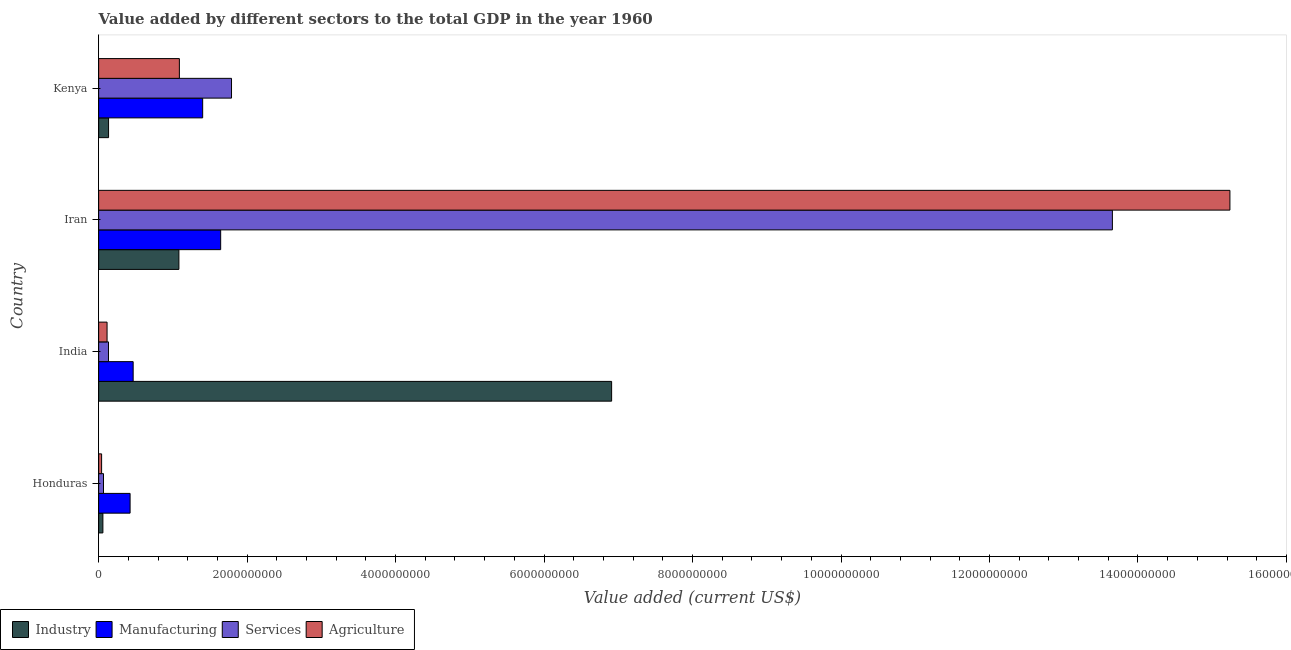How many groups of bars are there?
Make the answer very short. 4. Are the number of bars per tick equal to the number of legend labels?
Offer a very short reply. Yes. Are the number of bars on each tick of the Y-axis equal?
Make the answer very short. Yes. How many bars are there on the 3rd tick from the bottom?
Give a very brief answer. 4. What is the label of the 4th group of bars from the top?
Your response must be concise. Honduras. What is the value added by manufacturing sector in India?
Your answer should be compact. 4.65e+08. Across all countries, what is the maximum value added by industrial sector?
Your answer should be compact. 6.91e+09. Across all countries, what is the minimum value added by manufacturing sector?
Provide a succinct answer. 4.24e+08. In which country was the value added by services sector maximum?
Provide a short and direct response. Iran. In which country was the value added by services sector minimum?
Provide a short and direct response. Honduras. What is the total value added by agricultural sector in the graph?
Give a very brief answer. 1.65e+1. What is the difference between the value added by industrial sector in Honduras and that in Kenya?
Provide a short and direct response. -7.63e+07. What is the difference between the value added by services sector in Iran and the value added by manufacturing sector in India?
Provide a succinct answer. 1.32e+1. What is the average value added by agricultural sector per country?
Offer a terse response. 4.12e+09. What is the difference between the value added by industrial sector and value added by agricultural sector in India?
Your answer should be very brief. 6.80e+09. In how many countries, is the value added by services sector greater than 12000000000 US$?
Provide a short and direct response. 1. What is the ratio of the value added by manufacturing sector in Honduras to that in Kenya?
Offer a terse response. 0.3. Is the value added by agricultural sector in India less than that in Kenya?
Provide a succinct answer. Yes. Is the difference between the value added by industrial sector in Honduras and Kenya greater than the difference between the value added by services sector in Honduras and Kenya?
Provide a succinct answer. Yes. What is the difference between the highest and the second highest value added by agricultural sector?
Give a very brief answer. 1.42e+1. What is the difference between the highest and the lowest value added by manufacturing sector?
Provide a succinct answer. 1.22e+09. Is the sum of the value added by manufacturing sector in Honduras and Iran greater than the maximum value added by services sector across all countries?
Your response must be concise. No. What does the 1st bar from the top in Kenya represents?
Your answer should be compact. Agriculture. What does the 1st bar from the bottom in Kenya represents?
Give a very brief answer. Industry. How many bars are there?
Provide a short and direct response. 16. Are all the bars in the graph horizontal?
Your response must be concise. Yes. How many countries are there in the graph?
Offer a very short reply. 4. What is the difference between two consecutive major ticks on the X-axis?
Your answer should be very brief. 2.00e+09. Are the values on the major ticks of X-axis written in scientific E-notation?
Give a very brief answer. No. Does the graph contain any zero values?
Your answer should be compact. No. Where does the legend appear in the graph?
Your answer should be compact. Bottom left. How many legend labels are there?
Give a very brief answer. 4. How are the legend labels stacked?
Give a very brief answer. Horizontal. What is the title of the graph?
Offer a terse response. Value added by different sectors to the total GDP in the year 1960. Does "Public sector management" appear as one of the legend labels in the graph?
Provide a short and direct response. No. What is the label or title of the X-axis?
Offer a very short reply. Value added (current US$). What is the Value added (current US$) of Industry in Honduras?
Offer a very short reply. 5.73e+07. What is the Value added (current US$) in Manufacturing in Honduras?
Provide a short and direct response. 4.24e+08. What is the Value added (current US$) in Services in Honduras?
Keep it short and to the point. 6.55e+07. What is the Value added (current US$) in Agriculture in Honduras?
Offer a terse response. 4.01e+07. What is the Value added (current US$) of Industry in India?
Your answer should be very brief. 6.91e+09. What is the Value added (current US$) of Manufacturing in India?
Provide a short and direct response. 4.65e+08. What is the Value added (current US$) of Services in India?
Make the answer very short. 1.33e+08. What is the Value added (current US$) in Agriculture in India?
Offer a very short reply. 1.14e+08. What is the Value added (current US$) in Industry in Iran?
Your answer should be very brief. 1.08e+09. What is the Value added (current US$) in Manufacturing in Iran?
Keep it short and to the point. 1.64e+09. What is the Value added (current US$) in Services in Iran?
Provide a succinct answer. 1.37e+1. What is the Value added (current US$) of Agriculture in Iran?
Make the answer very short. 1.52e+1. What is the Value added (current US$) in Industry in Kenya?
Make the answer very short. 1.34e+08. What is the Value added (current US$) of Manufacturing in Kenya?
Keep it short and to the point. 1.40e+09. What is the Value added (current US$) of Services in Kenya?
Ensure brevity in your answer.  1.79e+09. What is the Value added (current US$) of Agriculture in Kenya?
Your answer should be compact. 1.09e+09. Across all countries, what is the maximum Value added (current US$) in Industry?
Your response must be concise. 6.91e+09. Across all countries, what is the maximum Value added (current US$) in Manufacturing?
Keep it short and to the point. 1.64e+09. Across all countries, what is the maximum Value added (current US$) in Services?
Offer a terse response. 1.37e+1. Across all countries, what is the maximum Value added (current US$) in Agriculture?
Your response must be concise. 1.52e+1. Across all countries, what is the minimum Value added (current US$) in Industry?
Provide a short and direct response. 5.73e+07. Across all countries, what is the minimum Value added (current US$) of Manufacturing?
Your answer should be very brief. 4.24e+08. Across all countries, what is the minimum Value added (current US$) of Services?
Offer a very short reply. 6.55e+07. Across all countries, what is the minimum Value added (current US$) in Agriculture?
Keep it short and to the point. 4.01e+07. What is the total Value added (current US$) of Industry in the graph?
Keep it short and to the point. 8.18e+09. What is the total Value added (current US$) of Manufacturing in the graph?
Provide a short and direct response. 3.93e+09. What is the total Value added (current US$) of Services in the graph?
Offer a terse response. 1.56e+1. What is the total Value added (current US$) in Agriculture in the graph?
Provide a short and direct response. 1.65e+1. What is the difference between the Value added (current US$) in Industry in Honduras and that in India?
Keep it short and to the point. -6.85e+09. What is the difference between the Value added (current US$) of Manufacturing in Honduras and that in India?
Make the answer very short. -4.13e+07. What is the difference between the Value added (current US$) in Services in Honduras and that in India?
Provide a short and direct response. -6.71e+07. What is the difference between the Value added (current US$) of Agriculture in Honduras and that in India?
Provide a short and direct response. -7.34e+07. What is the difference between the Value added (current US$) of Industry in Honduras and that in Iran?
Offer a terse response. -1.02e+09. What is the difference between the Value added (current US$) of Manufacturing in Honduras and that in Iran?
Your response must be concise. -1.22e+09. What is the difference between the Value added (current US$) in Services in Honduras and that in Iran?
Your answer should be very brief. -1.36e+1. What is the difference between the Value added (current US$) in Agriculture in Honduras and that in Iran?
Offer a terse response. -1.52e+1. What is the difference between the Value added (current US$) of Industry in Honduras and that in Kenya?
Offer a very short reply. -7.63e+07. What is the difference between the Value added (current US$) in Manufacturing in Honduras and that in Kenya?
Offer a very short reply. -9.78e+08. What is the difference between the Value added (current US$) in Services in Honduras and that in Kenya?
Make the answer very short. -1.72e+09. What is the difference between the Value added (current US$) of Agriculture in Honduras and that in Kenya?
Ensure brevity in your answer.  -1.05e+09. What is the difference between the Value added (current US$) in Industry in India and that in Iran?
Ensure brevity in your answer.  5.83e+09. What is the difference between the Value added (current US$) in Manufacturing in India and that in Iran?
Provide a succinct answer. -1.18e+09. What is the difference between the Value added (current US$) in Services in India and that in Iran?
Offer a very short reply. -1.35e+1. What is the difference between the Value added (current US$) in Agriculture in India and that in Iran?
Offer a very short reply. -1.51e+1. What is the difference between the Value added (current US$) in Industry in India and that in Kenya?
Provide a short and direct response. 6.78e+09. What is the difference between the Value added (current US$) in Manufacturing in India and that in Kenya?
Provide a succinct answer. -9.36e+08. What is the difference between the Value added (current US$) in Services in India and that in Kenya?
Give a very brief answer. -1.66e+09. What is the difference between the Value added (current US$) in Agriculture in India and that in Kenya?
Ensure brevity in your answer.  -9.74e+08. What is the difference between the Value added (current US$) of Industry in Iran and that in Kenya?
Keep it short and to the point. 9.48e+08. What is the difference between the Value added (current US$) in Manufacturing in Iran and that in Kenya?
Offer a very short reply. 2.43e+08. What is the difference between the Value added (current US$) of Services in Iran and that in Kenya?
Offer a very short reply. 1.19e+1. What is the difference between the Value added (current US$) of Agriculture in Iran and that in Kenya?
Make the answer very short. 1.42e+1. What is the difference between the Value added (current US$) in Industry in Honduras and the Value added (current US$) in Manufacturing in India?
Your answer should be very brief. -4.08e+08. What is the difference between the Value added (current US$) in Industry in Honduras and the Value added (current US$) in Services in India?
Offer a very short reply. -7.53e+07. What is the difference between the Value added (current US$) in Industry in Honduras and the Value added (current US$) in Agriculture in India?
Make the answer very short. -5.62e+07. What is the difference between the Value added (current US$) of Manufacturing in Honduras and the Value added (current US$) of Services in India?
Your answer should be compact. 2.91e+08. What is the difference between the Value added (current US$) of Manufacturing in Honduras and the Value added (current US$) of Agriculture in India?
Offer a very short reply. 3.10e+08. What is the difference between the Value added (current US$) in Services in Honduras and the Value added (current US$) in Agriculture in India?
Provide a short and direct response. -4.80e+07. What is the difference between the Value added (current US$) in Industry in Honduras and the Value added (current US$) in Manufacturing in Iran?
Keep it short and to the point. -1.59e+09. What is the difference between the Value added (current US$) of Industry in Honduras and the Value added (current US$) of Services in Iran?
Ensure brevity in your answer.  -1.36e+1. What is the difference between the Value added (current US$) of Industry in Honduras and the Value added (current US$) of Agriculture in Iran?
Give a very brief answer. -1.52e+1. What is the difference between the Value added (current US$) in Manufacturing in Honduras and the Value added (current US$) in Services in Iran?
Offer a very short reply. -1.32e+1. What is the difference between the Value added (current US$) of Manufacturing in Honduras and the Value added (current US$) of Agriculture in Iran?
Your response must be concise. -1.48e+1. What is the difference between the Value added (current US$) of Services in Honduras and the Value added (current US$) of Agriculture in Iran?
Provide a short and direct response. -1.52e+1. What is the difference between the Value added (current US$) of Industry in Honduras and the Value added (current US$) of Manufacturing in Kenya?
Your answer should be very brief. -1.34e+09. What is the difference between the Value added (current US$) in Industry in Honduras and the Value added (current US$) in Services in Kenya?
Provide a succinct answer. -1.73e+09. What is the difference between the Value added (current US$) of Industry in Honduras and the Value added (current US$) of Agriculture in Kenya?
Your response must be concise. -1.03e+09. What is the difference between the Value added (current US$) of Manufacturing in Honduras and the Value added (current US$) of Services in Kenya?
Your answer should be very brief. -1.37e+09. What is the difference between the Value added (current US$) in Manufacturing in Honduras and the Value added (current US$) in Agriculture in Kenya?
Provide a short and direct response. -6.64e+08. What is the difference between the Value added (current US$) of Services in Honduras and the Value added (current US$) of Agriculture in Kenya?
Provide a succinct answer. -1.02e+09. What is the difference between the Value added (current US$) in Industry in India and the Value added (current US$) in Manufacturing in Iran?
Keep it short and to the point. 5.27e+09. What is the difference between the Value added (current US$) in Industry in India and the Value added (current US$) in Services in Iran?
Your response must be concise. -6.75e+09. What is the difference between the Value added (current US$) of Industry in India and the Value added (current US$) of Agriculture in Iran?
Make the answer very short. -8.33e+09. What is the difference between the Value added (current US$) in Manufacturing in India and the Value added (current US$) in Services in Iran?
Offer a terse response. -1.32e+1. What is the difference between the Value added (current US$) in Manufacturing in India and the Value added (current US$) in Agriculture in Iran?
Your response must be concise. -1.48e+1. What is the difference between the Value added (current US$) of Services in India and the Value added (current US$) of Agriculture in Iran?
Your response must be concise. -1.51e+1. What is the difference between the Value added (current US$) in Industry in India and the Value added (current US$) in Manufacturing in Kenya?
Your answer should be compact. 5.51e+09. What is the difference between the Value added (current US$) of Industry in India and the Value added (current US$) of Services in Kenya?
Ensure brevity in your answer.  5.12e+09. What is the difference between the Value added (current US$) in Industry in India and the Value added (current US$) in Agriculture in Kenya?
Your response must be concise. 5.82e+09. What is the difference between the Value added (current US$) of Manufacturing in India and the Value added (current US$) of Services in Kenya?
Provide a succinct answer. -1.32e+09. What is the difference between the Value added (current US$) of Manufacturing in India and the Value added (current US$) of Agriculture in Kenya?
Make the answer very short. -6.22e+08. What is the difference between the Value added (current US$) of Services in India and the Value added (current US$) of Agriculture in Kenya?
Ensure brevity in your answer.  -9.55e+08. What is the difference between the Value added (current US$) in Industry in Iran and the Value added (current US$) in Manufacturing in Kenya?
Your response must be concise. -3.20e+08. What is the difference between the Value added (current US$) in Industry in Iran and the Value added (current US$) in Services in Kenya?
Offer a terse response. -7.09e+08. What is the difference between the Value added (current US$) in Industry in Iran and the Value added (current US$) in Agriculture in Kenya?
Provide a succinct answer. -6.43e+06. What is the difference between the Value added (current US$) of Manufacturing in Iran and the Value added (current US$) of Services in Kenya?
Keep it short and to the point. -1.46e+08. What is the difference between the Value added (current US$) of Manufacturing in Iran and the Value added (current US$) of Agriculture in Kenya?
Give a very brief answer. 5.56e+08. What is the difference between the Value added (current US$) in Services in Iran and the Value added (current US$) in Agriculture in Kenya?
Ensure brevity in your answer.  1.26e+1. What is the average Value added (current US$) in Industry per country?
Your answer should be very brief. 2.05e+09. What is the average Value added (current US$) of Manufacturing per country?
Ensure brevity in your answer.  9.84e+08. What is the average Value added (current US$) of Services per country?
Provide a succinct answer. 3.91e+09. What is the average Value added (current US$) of Agriculture per country?
Offer a terse response. 4.12e+09. What is the difference between the Value added (current US$) of Industry and Value added (current US$) of Manufacturing in Honduras?
Provide a succinct answer. -3.66e+08. What is the difference between the Value added (current US$) of Industry and Value added (current US$) of Services in Honduras?
Offer a terse response. -8.21e+06. What is the difference between the Value added (current US$) in Industry and Value added (current US$) in Agriculture in Honduras?
Give a very brief answer. 1.72e+07. What is the difference between the Value added (current US$) in Manufacturing and Value added (current US$) in Services in Honduras?
Give a very brief answer. 3.58e+08. What is the difference between the Value added (current US$) of Manufacturing and Value added (current US$) of Agriculture in Honduras?
Your answer should be compact. 3.84e+08. What is the difference between the Value added (current US$) in Services and Value added (current US$) in Agriculture in Honduras?
Provide a succinct answer. 2.54e+07. What is the difference between the Value added (current US$) in Industry and Value added (current US$) in Manufacturing in India?
Keep it short and to the point. 6.44e+09. What is the difference between the Value added (current US$) in Industry and Value added (current US$) in Services in India?
Give a very brief answer. 6.78e+09. What is the difference between the Value added (current US$) in Industry and Value added (current US$) in Agriculture in India?
Provide a short and direct response. 6.80e+09. What is the difference between the Value added (current US$) of Manufacturing and Value added (current US$) of Services in India?
Provide a short and direct response. 3.33e+08. What is the difference between the Value added (current US$) of Manufacturing and Value added (current US$) of Agriculture in India?
Ensure brevity in your answer.  3.52e+08. What is the difference between the Value added (current US$) of Services and Value added (current US$) of Agriculture in India?
Your answer should be very brief. 1.91e+07. What is the difference between the Value added (current US$) in Industry and Value added (current US$) in Manufacturing in Iran?
Keep it short and to the point. -5.63e+08. What is the difference between the Value added (current US$) of Industry and Value added (current US$) of Services in Iran?
Your answer should be very brief. -1.26e+1. What is the difference between the Value added (current US$) of Industry and Value added (current US$) of Agriculture in Iran?
Give a very brief answer. -1.42e+1. What is the difference between the Value added (current US$) of Manufacturing and Value added (current US$) of Services in Iran?
Give a very brief answer. -1.20e+1. What is the difference between the Value added (current US$) in Manufacturing and Value added (current US$) in Agriculture in Iran?
Offer a very short reply. -1.36e+1. What is the difference between the Value added (current US$) in Services and Value added (current US$) in Agriculture in Iran?
Provide a short and direct response. -1.58e+09. What is the difference between the Value added (current US$) of Industry and Value added (current US$) of Manufacturing in Kenya?
Keep it short and to the point. -1.27e+09. What is the difference between the Value added (current US$) of Industry and Value added (current US$) of Services in Kenya?
Your answer should be very brief. -1.66e+09. What is the difference between the Value added (current US$) in Industry and Value added (current US$) in Agriculture in Kenya?
Keep it short and to the point. -9.54e+08. What is the difference between the Value added (current US$) in Manufacturing and Value added (current US$) in Services in Kenya?
Provide a succinct answer. -3.89e+08. What is the difference between the Value added (current US$) of Manufacturing and Value added (current US$) of Agriculture in Kenya?
Your answer should be compact. 3.14e+08. What is the difference between the Value added (current US$) of Services and Value added (current US$) of Agriculture in Kenya?
Provide a succinct answer. 7.02e+08. What is the ratio of the Value added (current US$) of Industry in Honduras to that in India?
Your answer should be compact. 0.01. What is the ratio of the Value added (current US$) in Manufacturing in Honduras to that in India?
Your response must be concise. 0.91. What is the ratio of the Value added (current US$) in Services in Honduras to that in India?
Provide a succinct answer. 0.49. What is the ratio of the Value added (current US$) in Agriculture in Honduras to that in India?
Make the answer very short. 0.35. What is the ratio of the Value added (current US$) in Industry in Honduras to that in Iran?
Make the answer very short. 0.05. What is the ratio of the Value added (current US$) in Manufacturing in Honduras to that in Iran?
Provide a short and direct response. 0.26. What is the ratio of the Value added (current US$) of Services in Honduras to that in Iran?
Give a very brief answer. 0. What is the ratio of the Value added (current US$) in Agriculture in Honduras to that in Iran?
Your response must be concise. 0. What is the ratio of the Value added (current US$) of Industry in Honduras to that in Kenya?
Give a very brief answer. 0.43. What is the ratio of the Value added (current US$) of Manufacturing in Honduras to that in Kenya?
Offer a very short reply. 0.3. What is the ratio of the Value added (current US$) of Services in Honduras to that in Kenya?
Your answer should be compact. 0.04. What is the ratio of the Value added (current US$) in Agriculture in Honduras to that in Kenya?
Your answer should be compact. 0.04. What is the ratio of the Value added (current US$) of Industry in India to that in Iran?
Make the answer very short. 6.39. What is the ratio of the Value added (current US$) of Manufacturing in India to that in Iran?
Offer a terse response. 0.28. What is the ratio of the Value added (current US$) of Services in India to that in Iran?
Your answer should be very brief. 0.01. What is the ratio of the Value added (current US$) in Agriculture in India to that in Iran?
Make the answer very short. 0.01. What is the ratio of the Value added (current US$) in Industry in India to that in Kenya?
Provide a short and direct response. 51.7. What is the ratio of the Value added (current US$) of Manufacturing in India to that in Kenya?
Your response must be concise. 0.33. What is the ratio of the Value added (current US$) of Services in India to that in Kenya?
Your answer should be very brief. 0.07. What is the ratio of the Value added (current US$) of Agriculture in India to that in Kenya?
Keep it short and to the point. 0.1. What is the ratio of the Value added (current US$) of Industry in Iran to that in Kenya?
Keep it short and to the point. 8.09. What is the ratio of the Value added (current US$) in Manufacturing in Iran to that in Kenya?
Offer a very short reply. 1.17. What is the ratio of the Value added (current US$) in Services in Iran to that in Kenya?
Your answer should be compact. 7.63. What is the ratio of the Value added (current US$) in Agriculture in Iran to that in Kenya?
Offer a terse response. 14.01. What is the difference between the highest and the second highest Value added (current US$) in Industry?
Give a very brief answer. 5.83e+09. What is the difference between the highest and the second highest Value added (current US$) in Manufacturing?
Your response must be concise. 2.43e+08. What is the difference between the highest and the second highest Value added (current US$) of Services?
Your response must be concise. 1.19e+1. What is the difference between the highest and the second highest Value added (current US$) of Agriculture?
Offer a very short reply. 1.42e+1. What is the difference between the highest and the lowest Value added (current US$) in Industry?
Keep it short and to the point. 6.85e+09. What is the difference between the highest and the lowest Value added (current US$) in Manufacturing?
Keep it short and to the point. 1.22e+09. What is the difference between the highest and the lowest Value added (current US$) in Services?
Your response must be concise. 1.36e+1. What is the difference between the highest and the lowest Value added (current US$) in Agriculture?
Ensure brevity in your answer.  1.52e+1. 